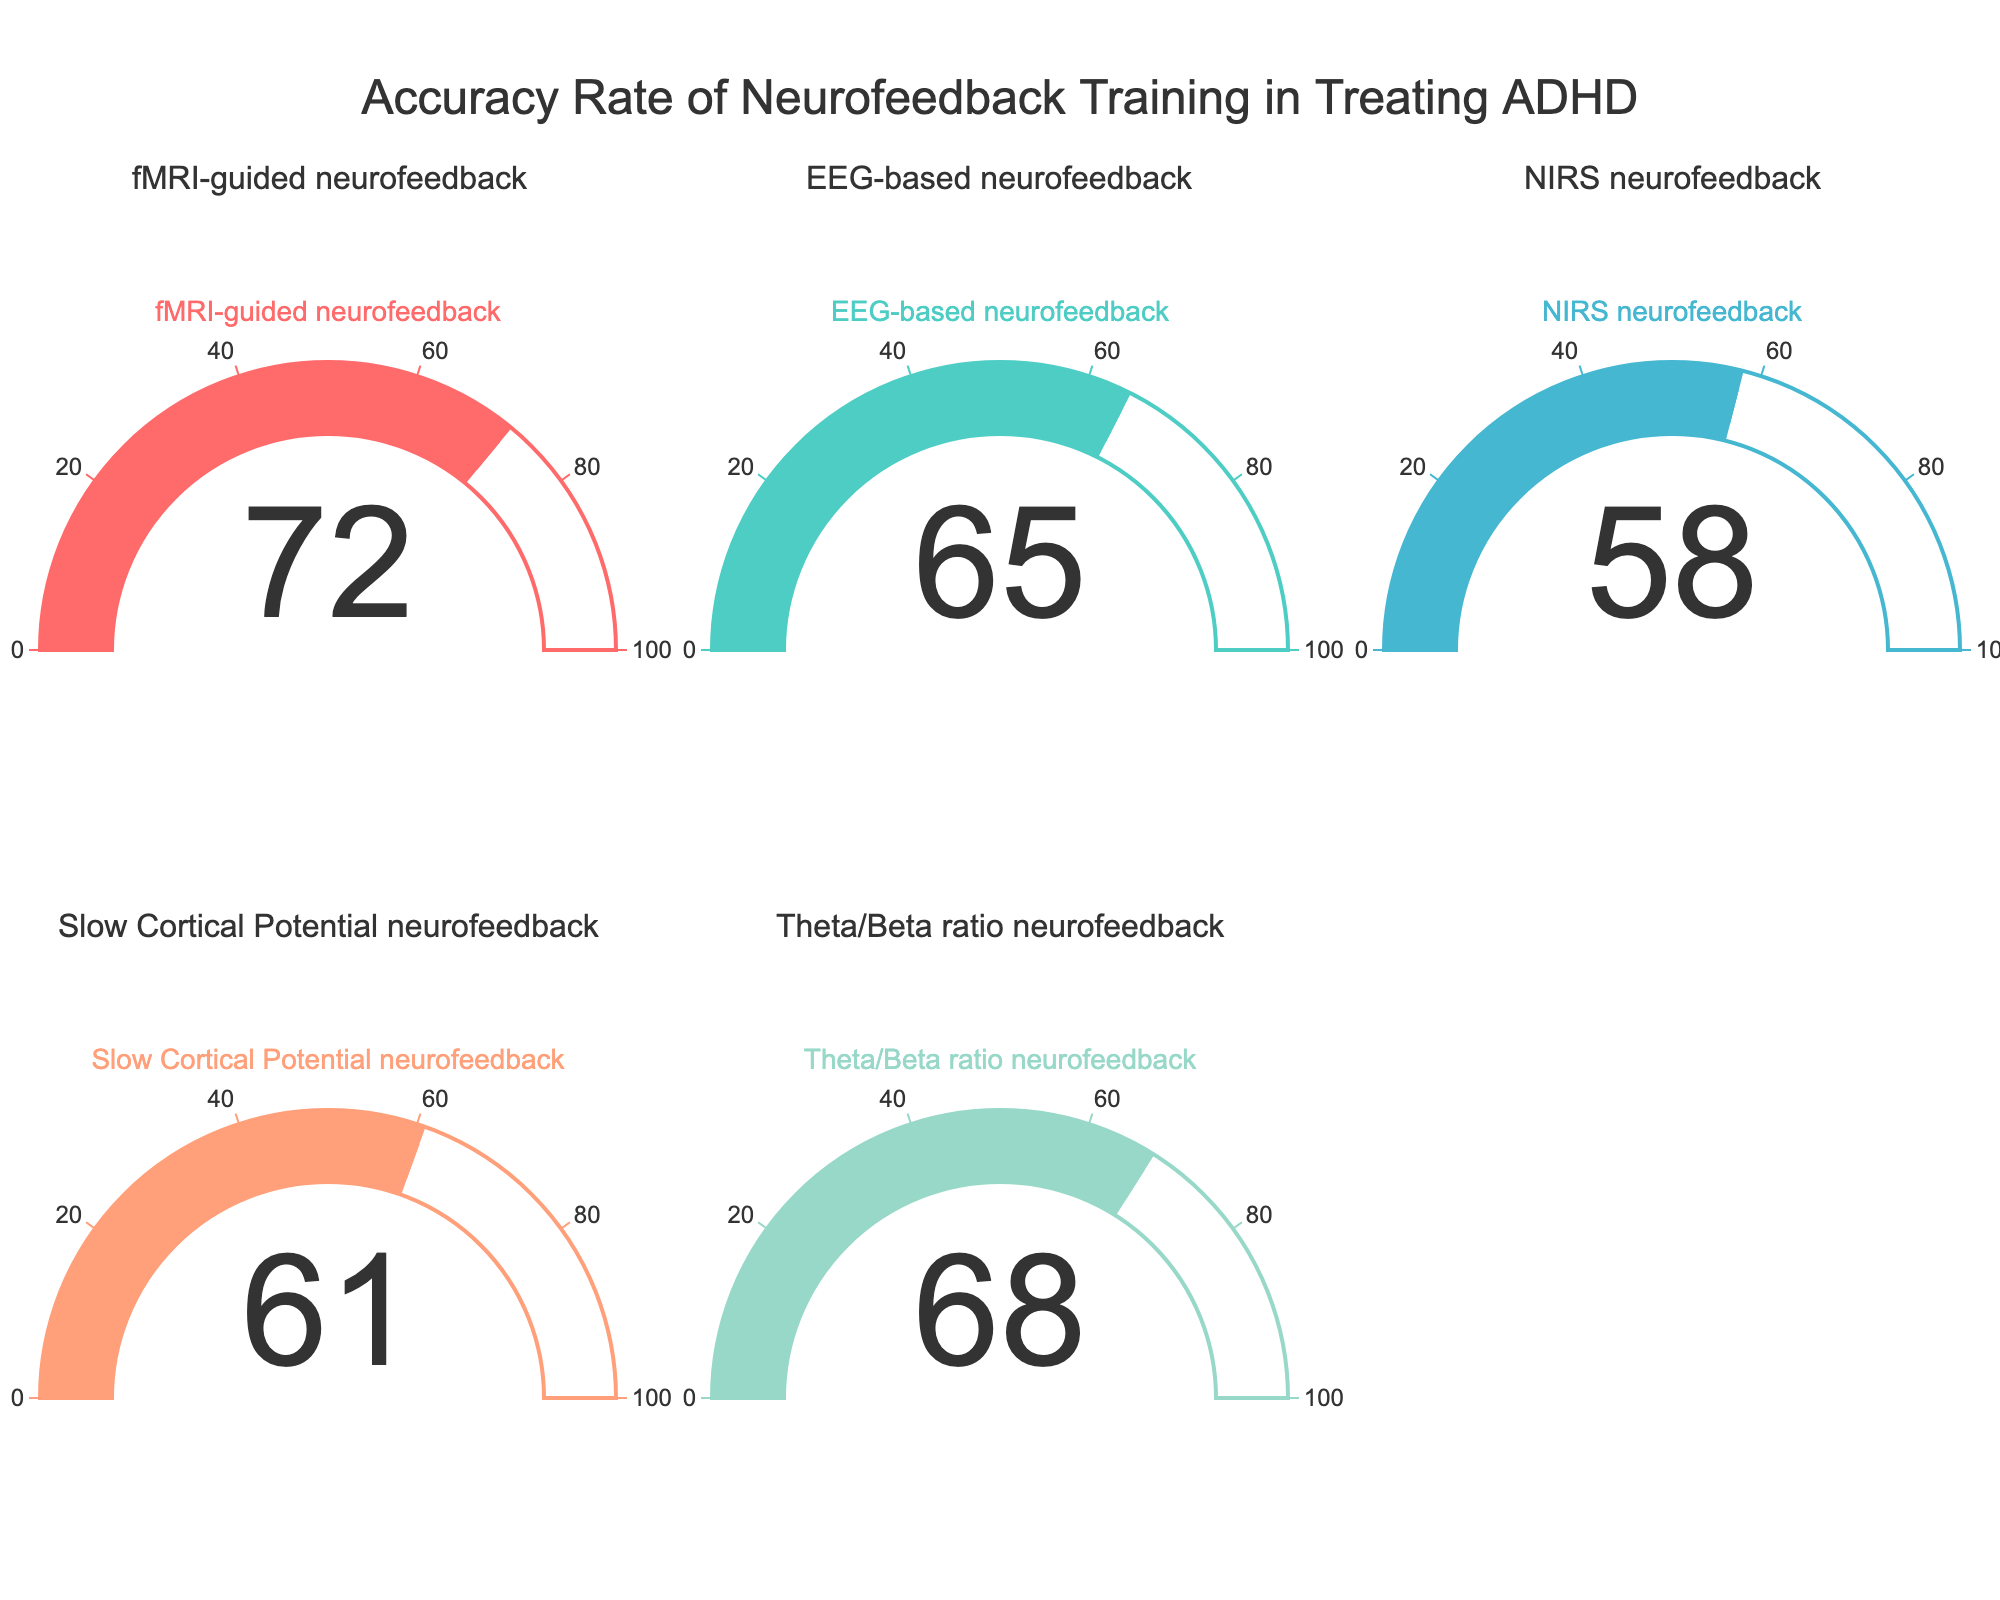What is the accuracy rate of fMRI-guided neurofeedback? The gauge chart shows the accuracy rate of fMRI-guided neurofeedback at 72.
Answer: 72 Which neurofeedback method has the lowest accuracy rate? Among the gauges, NIRS neurofeedback has the lowest accuracy rate at 58.
Answer: NIRS neurofeedback Which neurofeedback method has the highest accuracy rate? The highest accuracy rate shown is for fMRI-guided neurofeedback at 72.
Answer: fMRI-guided neurofeedback What is the difference in accuracy rates between fMRI-guided neurofeedback and NIRS neurofeedback? The gauge for fMRI-guided neurofeedback shows 72, and the gauge for NIRS neurofeedback shows 58. The difference is 72 - 58 = 14.
Answer: 14 What is the average accuracy rate of all the neurofeedback methods? Sum the accuracy rates (72 + 65 + 58 + 61 + 68) = 324 and divide by the number of methods, which is 5. The average is 324 / 5 = 64.8.
Answer: 64.8 Which two neurofeedback methods have accuracy rates closest to each other? Comparing the values, the most similar rates are EEG-based neurofeedback at 65, and Theta/Beta ratio neurofeedback at 68, with a difference of 3.
Answer: EEG-based and Theta/Beta ratio neurofeedback How many neurofeedback methods have higher accuracy rates than NIRS neurofeedback? NIRS neurofeedback has an accuracy rate of 58. The methods with higher rates are fMRI-guided (72), EEG-based (65), Slow Cortical Potential (61), and Theta/Beta ratio (68). So, there are 4 methods.
Answer: 4 Is the accuracy rate of Theta/Beta ratio neurofeedback higher than that of Slow Cortical Potential neurofeedback? Comparing the values, Theta/Beta ratio neurofeedback shows 68 while Slow Cortical Potential neurofeedback shows 61. Thus, 68 > 61.
Answer: Yes What is the combined accuracy rate of EEG-based and Slow Cortical Potential neurofeedback methods? Adding the accuracy rates, EEG-based neurofeedback has 65 and Slow Cortical Potential neurofeedback has 61. The combined rate is 65 + 61 = 126.
Answer: 126 